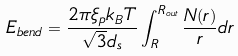<formula> <loc_0><loc_0><loc_500><loc_500>E _ { b e n d } = \frac { 2 \pi \xi _ { p } k _ { B } T } { \sqrt { 3 } d _ { s } } \int _ { R } ^ { R _ { o u t } } \frac { N ( r ) } { r } d r</formula> 